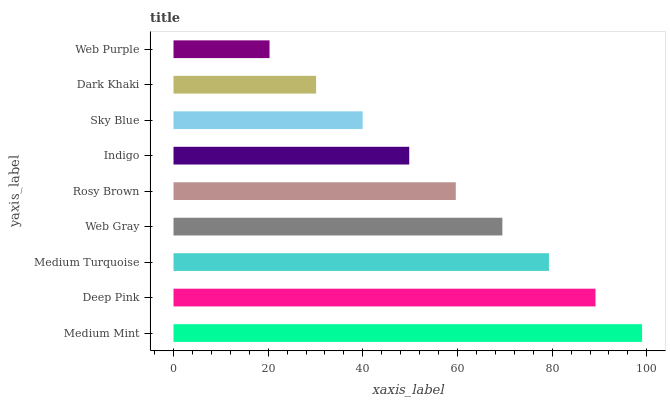Is Web Purple the minimum?
Answer yes or no. Yes. Is Medium Mint the maximum?
Answer yes or no. Yes. Is Deep Pink the minimum?
Answer yes or no. No. Is Deep Pink the maximum?
Answer yes or no. No. Is Medium Mint greater than Deep Pink?
Answer yes or no. Yes. Is Deep Pink less than Medium Mint?
Answer yes or no. Yes. Is Deep Pink greater than Medium Mint?
Answer yes or no. No. Is Medium Mint less than Deep Pink?
Answer yes or no. No. Is Rosy Brown the high median?
Answer yes or no. Yes. Is Rosy Brown the low median?
Answer yes or no. Yes. Is Dark Khaki the high median?
Answer yes or no. No. Is Web Gray the low median?
Answer yes or no. No. 